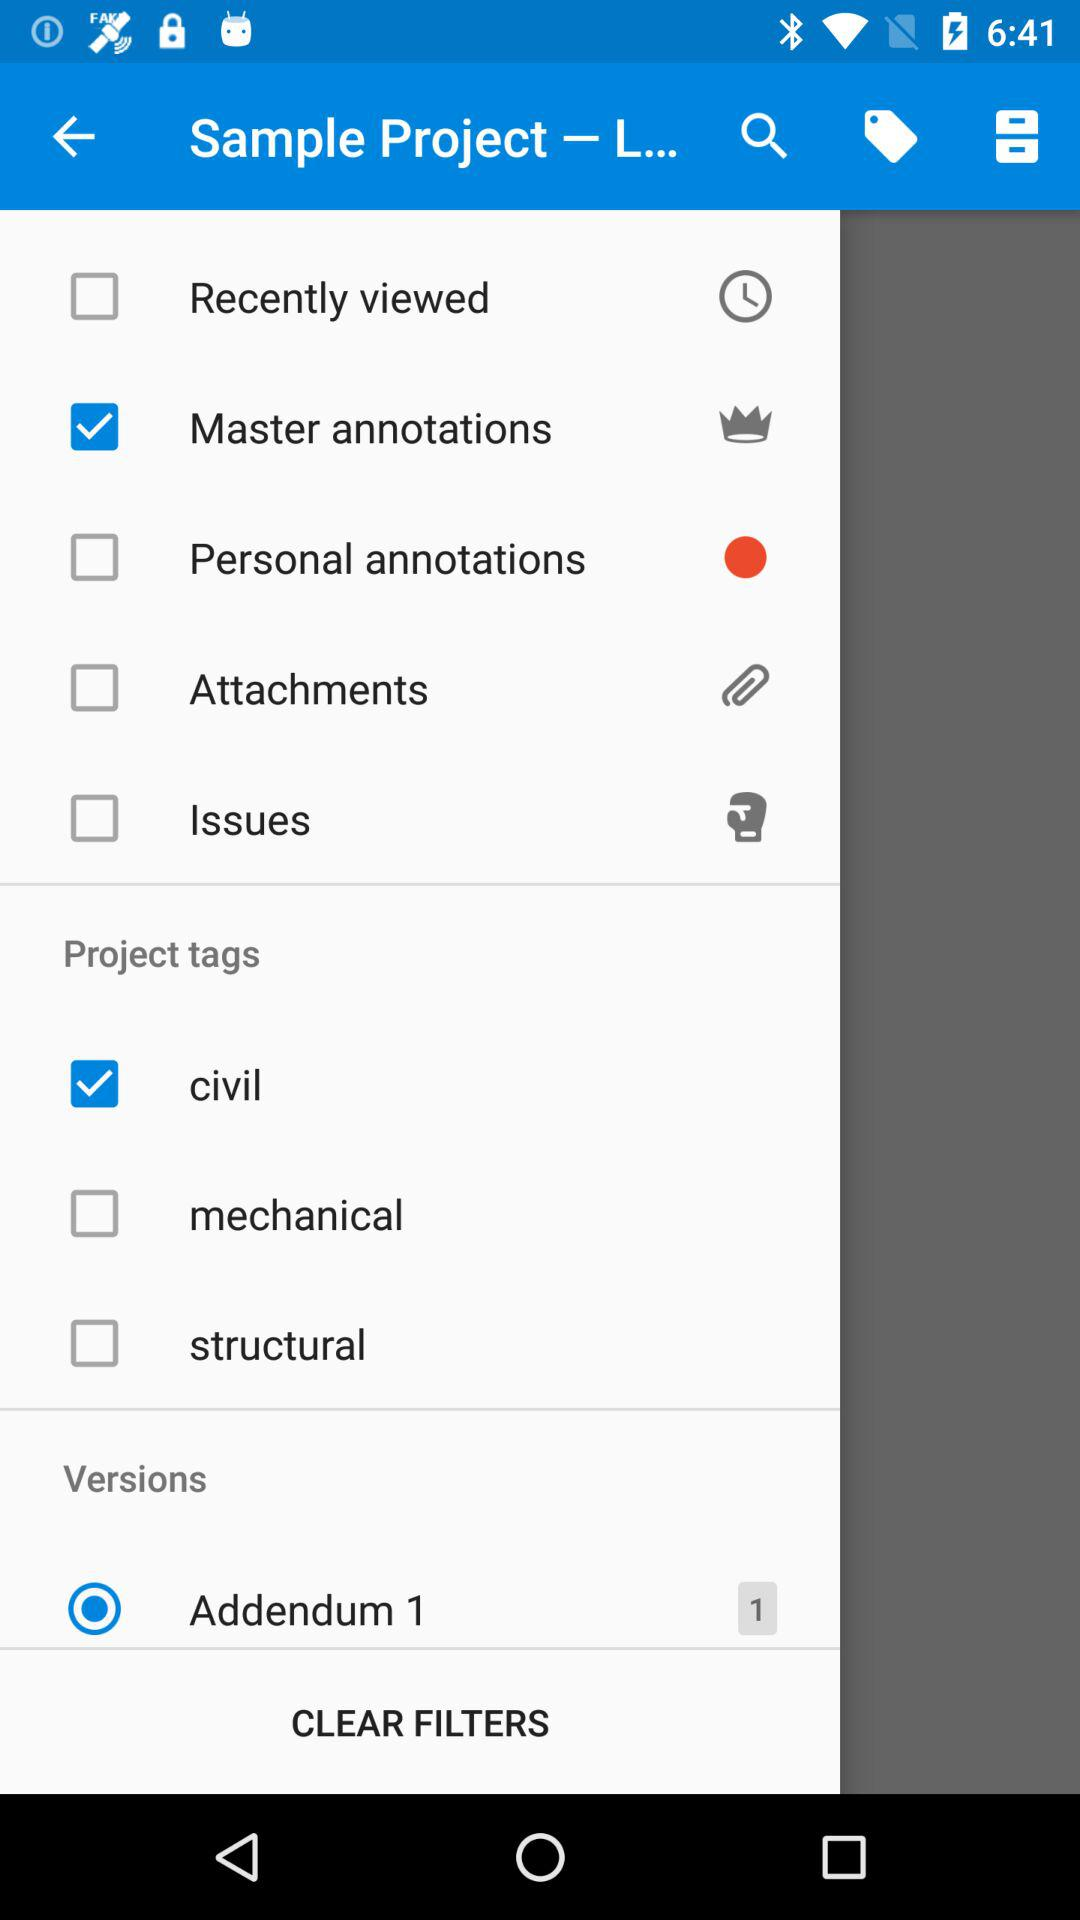What is the status of "Addendum 1"? The status is "on". 